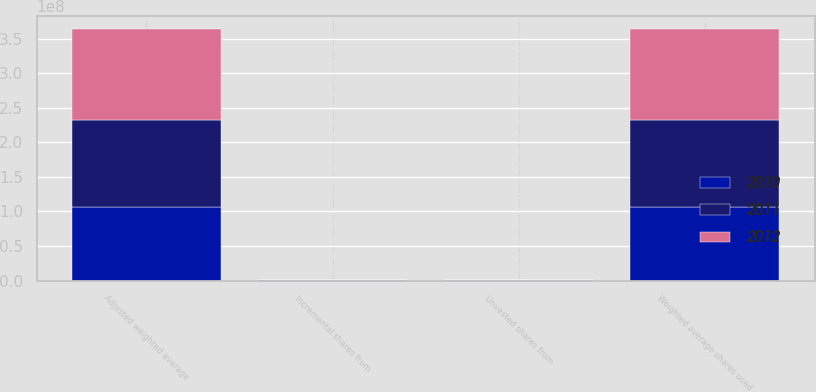<chart> <loc_0><loc_0><loc_500><loc_500><stacked_bar_chart><ecel><fcel>Weighted average shares used<fcel>Incremental shares from<fcel>Adjusted weighted average<fcel>Unvested shares from<nl><fcel>2012<fcel>1.32817e+08<fcel>67461<fcel>1.32885e+08<fcel>17570<nl><fcel>2011<fcel>1.26143e+08<fcel>46703<fcel>1.26189e+08<fcel>13020<nl><fcel>2010<fcel>1.0587e+08<fcel>73084<fcel>1.05943e+08<fcel>87600<nl></chart> 